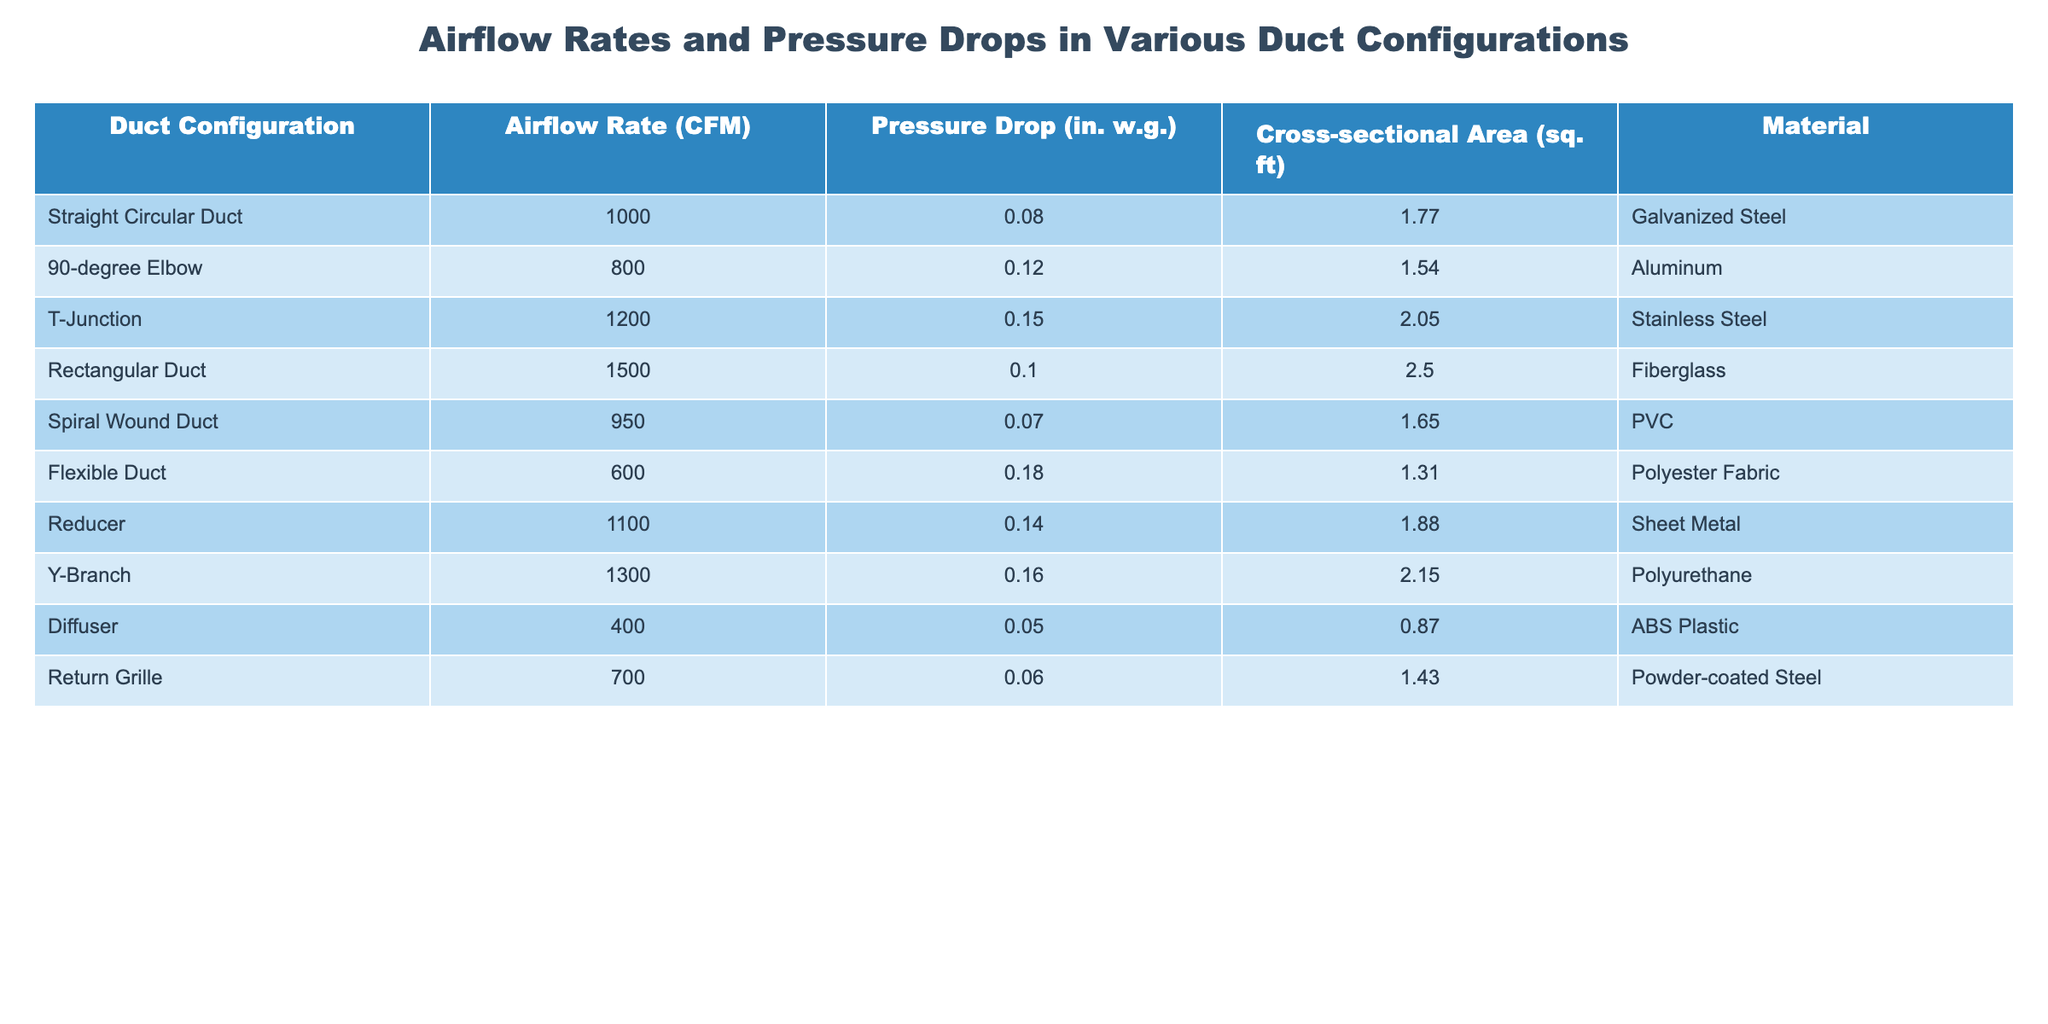What is the airflow rate of the Rectangular Duct? The table shows that the airflow rate for the Rectangular Duct is listed under the "Airflow Rate (CFM)" column, where it has a value of 1500 CFM.
Answer: 1500 CFM Which duct configuration has the highest pressure drop? By examining the "Pressure Drop (in. w.g.)" column, the T-Junction has the highest value at 0.15 in. w.g, which is greater than the pressure drops for all other duct configurations listed in the table.
Answer: T-Junction What is the average airflow rate of all duct configurations? To find the average airflow rate, we sum the airflow rates: (1000 + 800 + 1200 + 1500 + 950 + 600 + 1100 + 1300 + 400 + 700) = 7500 CFM. Then, divide by the number of configurations (10): 7500/10 = 750 CFM.
Answer: 750 CFM Is the flexible duct made of galvanized steel? The table indicates that the Flexible Duct is made of Polyester Fabric, not Galvanized Steel.
Answer: No Which duct configurations have a pressure drop less than 0.1 in. w.g.? By reviewing the "Pressure Drop (in. w.g.)" column, only the Straight Circular Duct (0.08 in. w.g.) and Diffuser (0.05 in. w.g.) have pressure drops less than 0.1 in. w.g.
Answer: Straight Circular Duct, Diffuser What is the difference in airflow rate between the T-Junction and the Flexible Duct? The airflow rate for the T-Junction is 1200 CFM, while for the Flexible Duct it is 600 CFM; thus, the difference is 1200 - 600 = 600 CFM.
Answer: 600 CFM How many duct configurations have an airflow rate greater than 1000 CFM? By inspecting the "Airflow Rate (CFM)" column, the configurations with airflow rates above 1000 CFM are Straight Circular Duct, T-Junction, Rectangular Duct, Reducer, Y-Branch, resulting in a total of 5 configurations.
Answer: 5 What material is used for the Spiral Wound Duct? According to the "Material" column, the Spiral Wound Duct is made of PVC.
Answer: PVC What is the combined pressure drop of the 90-degree Elbow and the Reducer? The pressure drop for the 90-degree Elbow is 0.12 in. w.g., and for the Reducer it is 0.14 in. w.g. Therefore, the combined pressure drop is 0.12 + 0.14 = 0.26 in. w.g.
Answer: 0.26 in. w.g Which configuration has the lowest airflow rate? The table shows that the Diffuser has the lowest airflow rate at 400 CFM when examining the "Airflow Rate (CFM)" column.
Answer: Diffuser 